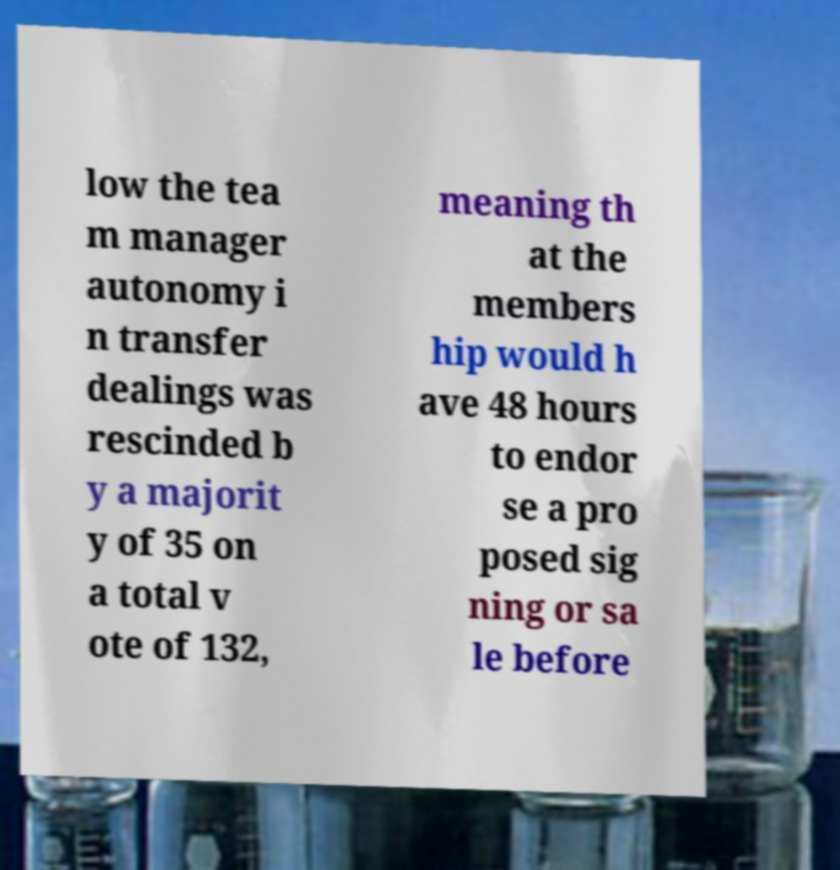Please read and relay the text visible in this image. What does it say? low the tea m manager autonomy i n transfer dealings was rescinded b y a majorit y of 35 on a total v ote of 132, meaning th at the members hip would h ave 48 hours to endor se a pro posed sig ning or sa le before 